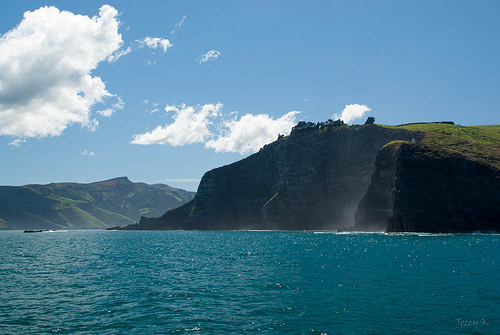<image>
Can you confirm if the water is behind the rock? No. The water is not behind the rock. From this viewpoint, the water appears to be positioned elsewhere in the scene. Is there a cliff above the ocean? No. The cliff is not positioned above the ocean. The vertical arrangement shows a different relationship. 